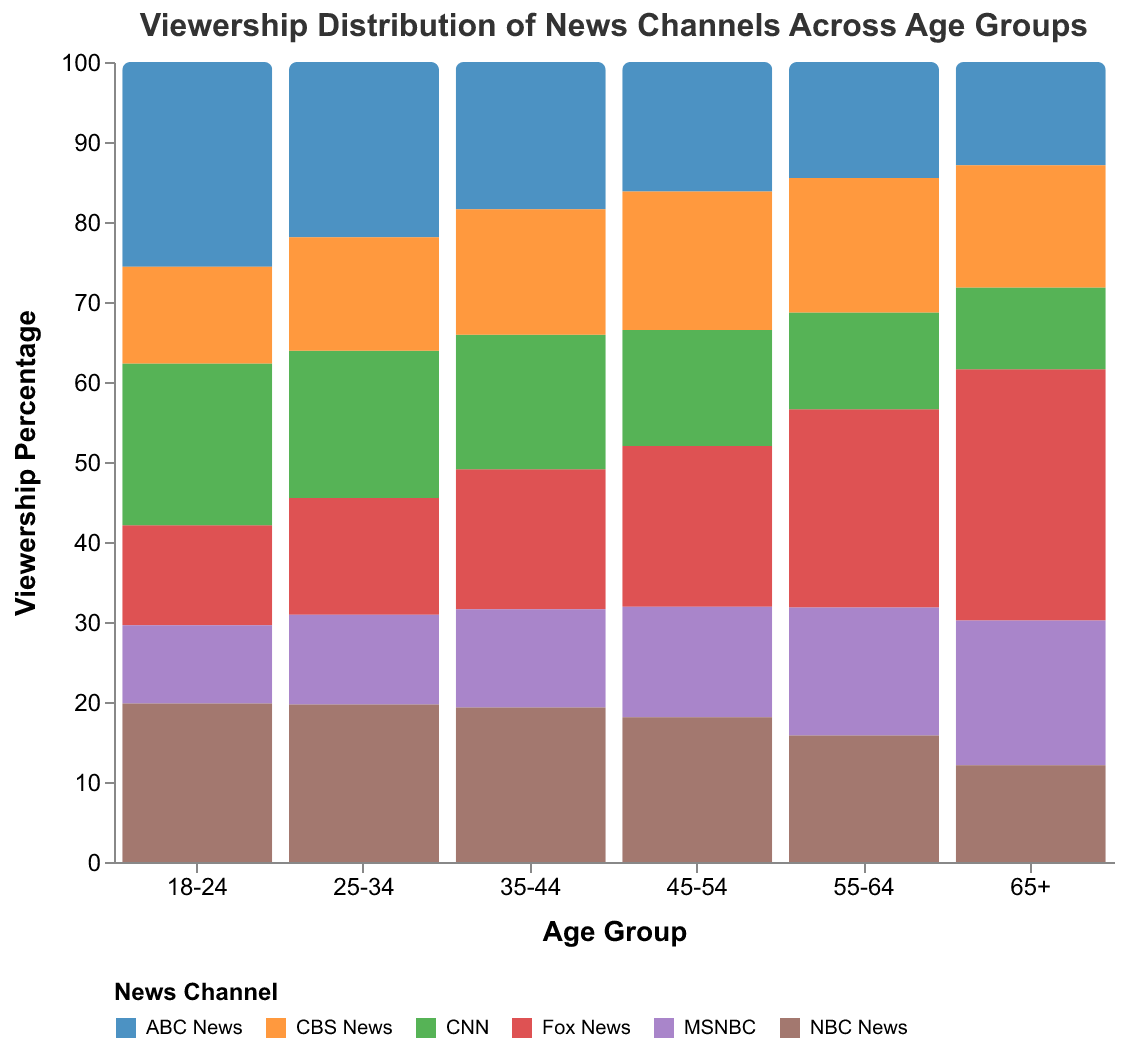What is the viewership percentage of ABC News in the age group 18-24? Find the bar corresponding to "ABC News" within the "18-24" age group and note the viewership percentage value.
Answer: 25.6% Which age group has the highest viewership percentage for Fox News? Compare the heights of the bars for "Fox News" across all age groups and identify the highest one. "65+" has the tallest bar with a viewership percentage of 31.4%.
Answer: 65+ What is the total viewership percentage of CNN across all age groups? Sum the viewership percentages for CNN across each age group: 20.2 + 18.4 + 16.8 + 14.5 + 12.1 + 10.2 = 92.2.
Answer: 92.2% Which news channel has the lowest viewership percentage in the age group 45-54? Compare the heights of all bars within the "45-54" age group. MSNBC has the lowest bar with a viewership percentage of 13.8%.
Answer: MSNBC Is the viewership percentage of Fox News greater than that of MSNBC in the age group 35-44? Compare the heights of the bars representing Fox News and MSNBC within the "35-44" age group. Fox News has a percentage of 17.5% and MSNBC has 12.3%.
Answer: Yes What is the average viewership percentage for NBC News across all age groups? Sum the viewership percentages for NBC News across each age group and divide by the number of age groups: (19.8 + 19.7 + 19.3 + 18.1 + 15.8 + 12.1) / 6 = 17.3.
Answer: 17.3% Which age group has the highest combined viewership percentage for all channels? Sum the viewership percentages of all channels across each age group and compare the totals. "55-64" has the highest combined total of 100 (24.8 + 12.1 + 16.0 + 14.5 + 16.8 + 15.8).
Answer: 55-64 Which news channel has the increasing trend in viewership percentage from youngest to oldest age group? Inspect the trend of bars for each channel from the youngest (18-24) to the oldest (65+). Fox News shows an increasing trend (12.5, 14.6, 17.5, 20.1, 24.8, 31.4).
Answer: Fox News 